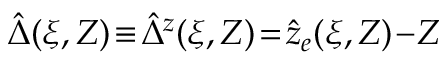Convert formula to latex. <formula><loc_0><loc_0><loc_500><loc_500>\hat { \Delta } ( \xi , Z ) \, \equiv \, \hat { \Delta } ^ { z } ( \xi , Z ) \, = \, \hat { z } _ { e } ( \xi , Z ) \, - \, Z</formula> 